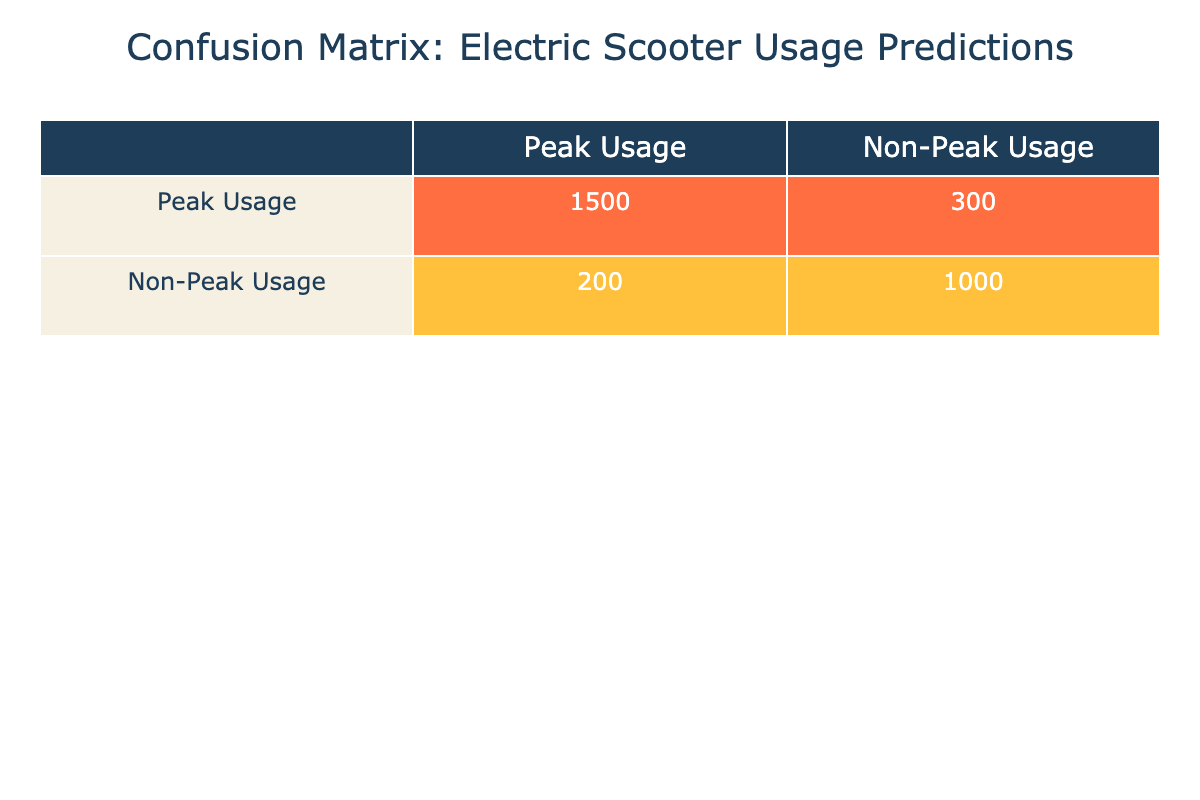What is the number of correct predictions for peak usage? The table shows the actual values versus the predicted values for peak and non-peak usage. For peak usage, the correct predictions are represented in the first row under 'Peak Usage,’ which is 1500.
Answer: 1500 What is the total number of predictions made for non-peak usage? To find the total predictions made for non-peak usage, we add the predicted values from the second row: 200 (false positives) + 1000 (true negatives) = 1200.
Answer: 1200 What percentage of peak usage predictions were correct? The number of correct peak usage predictions is 1500, and the total predictions for peak usage (true positives + false positives) is 1500 + 300 = 1800. The percentage is calculated as (1500 / 1800) * 100 = 83.33%.
Answer: 83.33% Is the number of incorrect predictions for non-peak usage greater than for peak usage? The number of incorrect predictions for non-peak usage can be calculated from the table as 200 (false positives) + 300 (false negatives) = 500. For peak usage, the incorrect predictions are 300 (false negatives). Since 500 > 300, the statement is true.
Answer: Yes What is the sum of correct predictions for both peak and non-peak usage? The correct predictions for peak usage is 1500, while for non-peak usage, it is 1000. The sum is 1500 + 1000 = 2500, representing both correct predictions combined.
Answer: 2500 What is the difference between incorrect predictions for peak and non-peak usage? The incorrect predictions for peak usage are 300 (false negatives) and for non-peak usage are 200 (false positives). The difference is calculated by subtracting the non-peak from the peak: 300 - 200 = 100.
Answer: 100 What is the total number of actual peak usage recorded? The actual peak usage is directly available in the table, which states there are 1800 (1500 correct + 300 incorrect). Thus, the total number of actual peak usage recorded is 1800.
Answer: 1800 Is the number of true positives equal to the number of true negatives? The number of true positives, which is correct predictions for peak usage, is 1500. The number of true negatives, which is correct predictions for non-peak usage, is 1000. Since 1500 is not equal to 1000, the statement is false.
Answer: No What is the expected prediction for peak usage if both usage types maintain their current proportions? Based on the current predictions, the proportion of peak usage is 1500 out of a total of 2800 (1500 + 300 + 200 + 1000). The expected prediction for peak usage would maintain this proportion. Thus, the expected peak prediction would be 2800 * (1500/2800) = 1500.
Answer: 1500 What is the total number of predictions for the entire dataset? The total number of predictions can be calculated by summing all values in the table: 1500 (true positives) + 300 (false positives) + 200 (false negatives) + 1000 (true negatives) = 3000.
Answer: 3000 